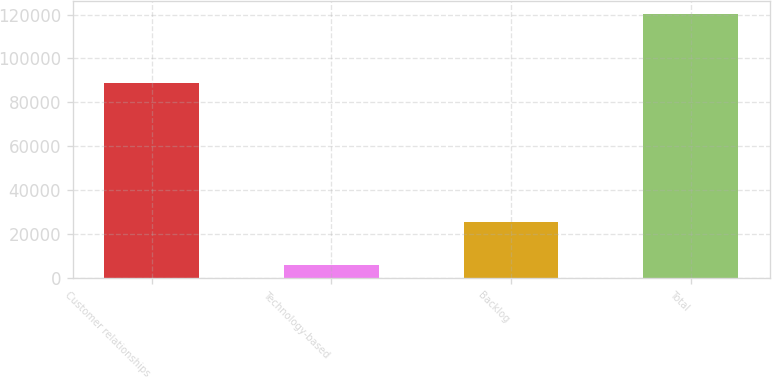Convert chart. <chart><loc_0><loc_0><loc_500><loc_500><bar_chart><fcel>Customer relationships<fcel>Technology-based<fcel>Backlog<fcel>Total<nl><fcel>88913<fcel>5934<fcel>25500<fcel>120347<nl></chart> 